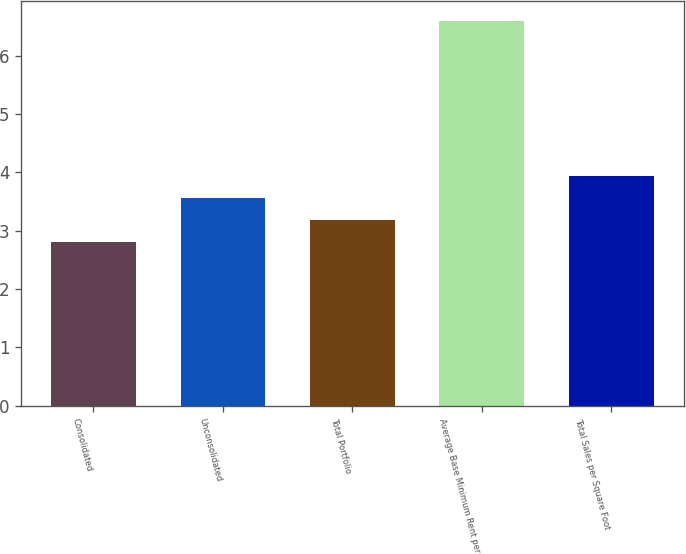Convert chart. <chart><loc_0><loc_0><loc_500><loc_500><bar_chart><fcel>Consolidated<fcel>Unconsolidated<fcel>Total Portfolio<fcel>Average Base Minimum Rent per<fcel>Total Sales per Square Foot<nl><fcel>2.8<fcel>3.56<fcel>3.18<fcel>6.6<fcel>3.94<nl></chart> 